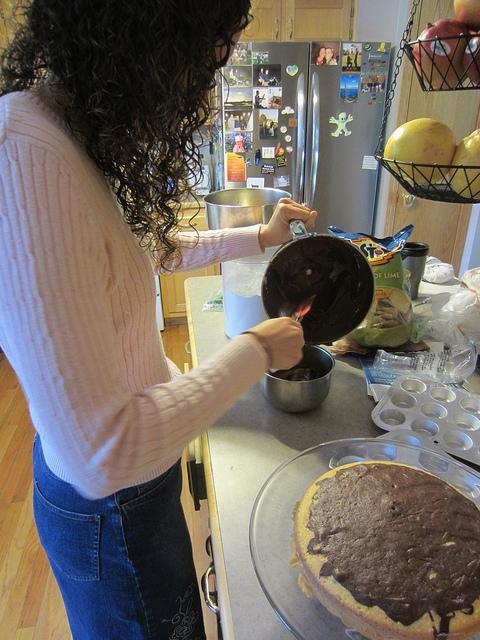How was the item on the plate cooked? Please explain your reasoning. oven. The cake was baked. 